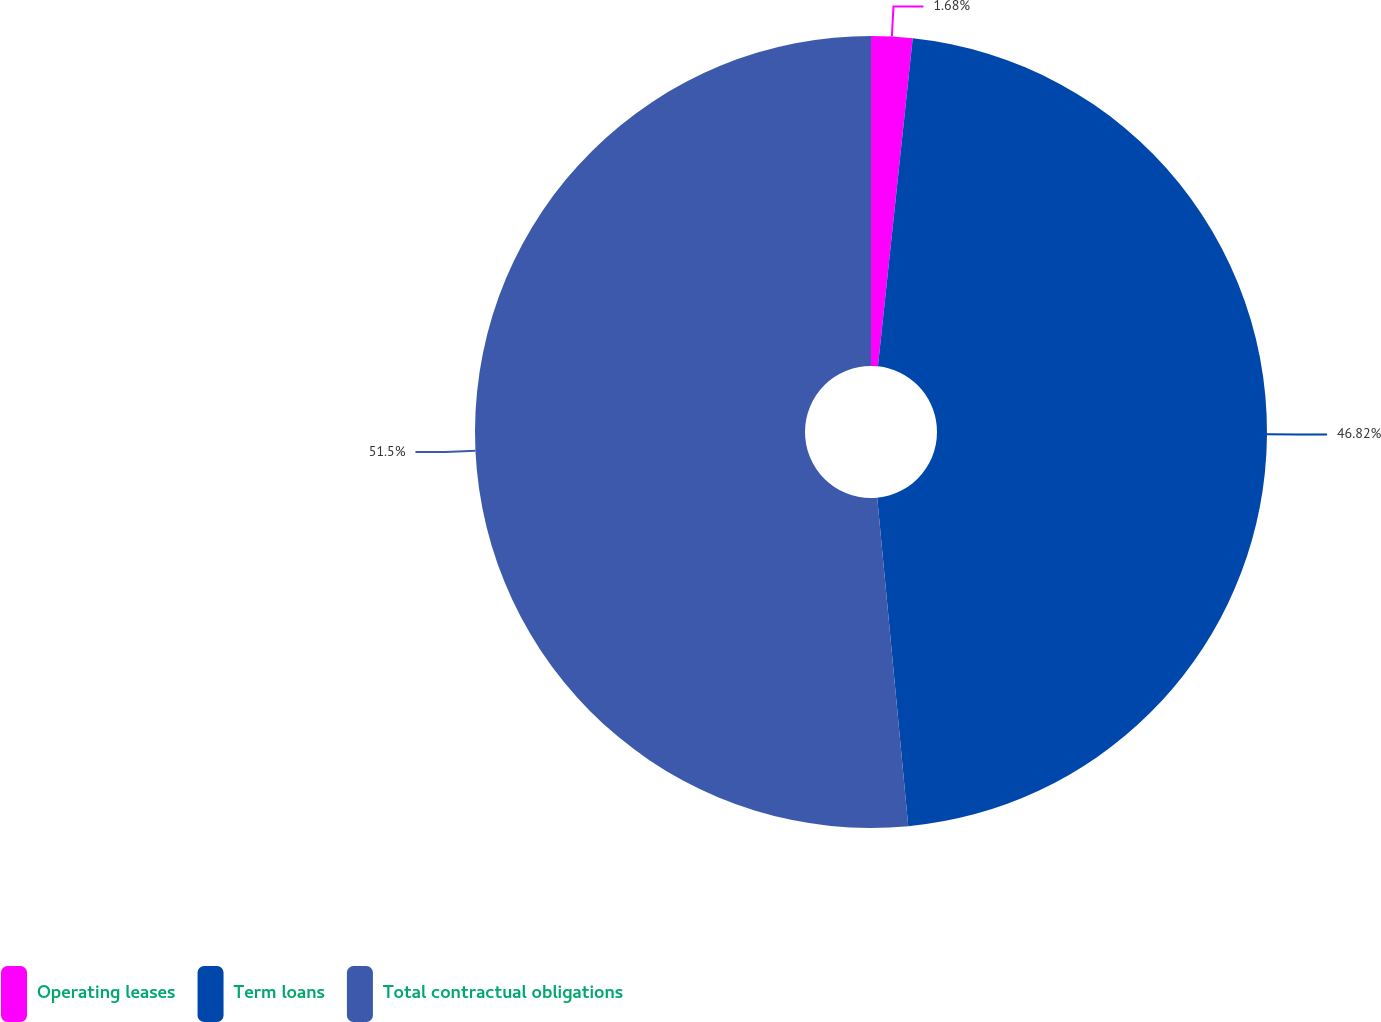Convert chart to OTSL. <chart><loc_0><loc_0><loc_500><loc_500><pie_chart><fcel>Operating leases<fcel>Term loans<fcel>Total contractual obligations<nl><fcel>1.68%<fcel>46.82%<fcel>51.5%<nl></chart> 